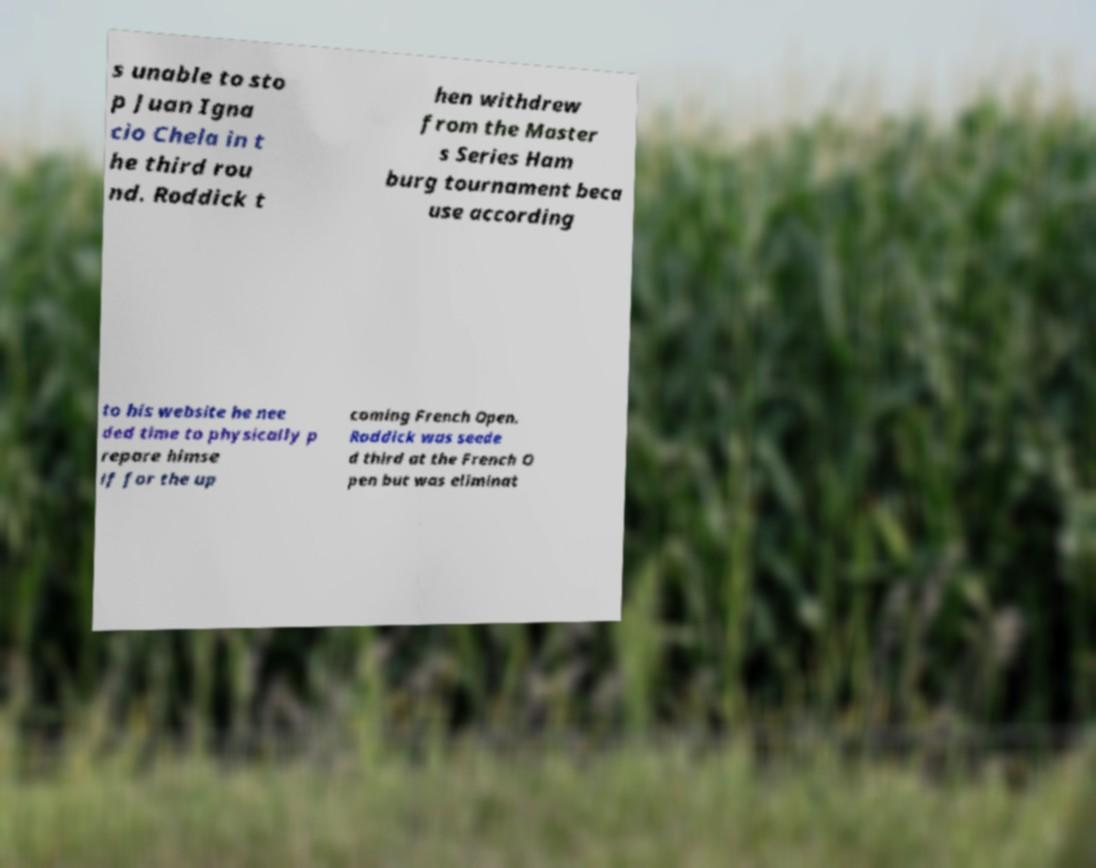For documentation purposes, I need the text within this image transcribed. Could you provide that? s unable to sto p Juan Igna cio Chela in t he third rou nd. Roddick t hen withdrew from the Master s Series Ham burg tournament beca use according to his website he nee ded time to physically p repare himse lf for the up coming French Open. Roddick was seede d third at the French O pen but was eliminat 